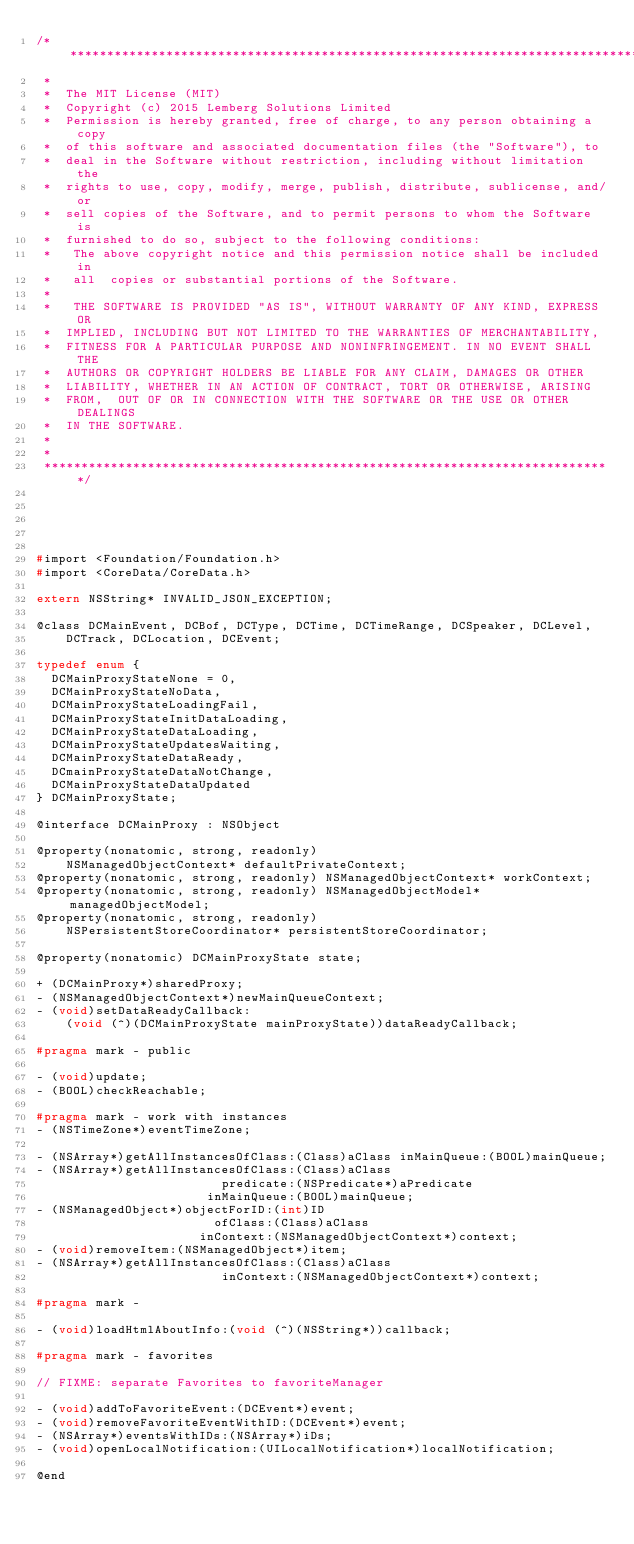<code> <loc_0><loc_0><loc_500><loc_500><_C_>/**********************************************************************************
 *                                                                           
 *  The MIT License (MIT)
 *  Copyright (c) 2015 Lemberg Solutions Limited
 *  Permission is hereby granted, free of charge, to any person obtaining a copy
 *  of this software and associated documentation files (the "Software"), to
 *  deal in the Software without restriction, including without limitation the 
 *  rights to use, copy, modify, merge, publish, distribute, sublicense, and/or
 *  sell copies of the Software, and to permit persons to whom the Software is
 *  furnished to do so, subject to the following conditions:
 *   The above copyright notice and this permission notice shall be included in
 *   all  copies or substantial portions of the Software.
 *
 *   THE SOFTWARE IS PROVIDED "AS IS", WITHOUT WARRANTY OF ANY KIND, EXPRESS OR
 *  IMPLIED, INCLUDING BUT NOT LIMITED TO THE WARRANTIES OF MERCHANTABILITY,
 *  FITNESS FOR A PARTICULAR PURPOSE AND NONINFRINGEMENT. IN NO EVENT SHALL THE
 *  AUTHORS OR COPYRIGHT HOLDERS BE LIABLE FOR ANY CLAIM, DAMAGES OR OTHER
 *  LIABILITY, WHETHER IN AN ACTION OF CONTRACT, TORT OR OTHERWISE, ARISING
 *  FROM,  OUT OF OR IN CONNECTION WITH THE SOFTWARE OR THE USE OR OTHER DEALINGS 
 *  IN THE SOFTWARE.
 *
 *                                                                           
 *****************************************************************************/





#import <Foundation/Foundation.h>
#import <CoreData/CoreData.h>

extern NSString* INVALID_JSON_EXCEPTION;

@class DCMainEvent, DCBof, DCType, DCTime, DCTimeRange, DCSpeaker, DCLevel,
    DCTrack, DCLocation, DCEvent;

typedef enum {
  DCMainProxyStateNone = 0,
  DCMainProxyStateNoData,
  DCMainProxyStateLoadingFail,
  DCMainProxyStateInitDataLoading,
  DCMainProxyStateDataLoading,
  DCMainProxyStateUpdatesWaiting,
  DCMainProxyStateDataReady,
  DCmainProxyStateDataNotChange,
  DCMainProxyStateDataUpdated
} DCMainProxyState;

@interface DCMainProxy : NSObject

@property(nonatomic, strong, readonly)
    NSManagedObjectContext* defaultPrivateContext;
@property(nonatomic, strong, readonly) NSManagedObjectContext* workContext;
@property(nonatomic, strong, readonly) NSManagedObjectModel* managedObjectModel;
@property(nonatomic, strong, readonly)
    NSPersistentStoreCoordinator* persistentStoreCoordinator;

@property(nonatomic) DCMainProxyState state;

+ (DCMainProxy*)sharedProxy;
- (NSManagedObjectContext*)newMainQueueContext;
- (void)setDataReadyCallback:
    (void (^)(DCMainProxyState mainProxyState))dataReadyCallback;

#pragma mark - public

- (void)update;
- (BOOL)checkReachable;

#pragma mark - work with instances
- (NSTimeZone*)eventTimeZone;

- (NSArray*)getAllInstancesOfClass:(Class)aClass inMainQueue:(BOOL)mainQueue;
- (NSArray*)getAllInstancesOfClass:(Class)aClass
                         predicate:(NSPredicate*)aPredicate
                       inMainQueue:(BOOL)mainQueue;
- (NSManagedObject*)objectForID:(int)ID
                        ofClass:(Class)aClass
                      inContext:(NSManagedObjectContext*)context;
- (void)removeItem:(NSManagedObject*)item;
- (NSArray*)getAllInstancesOfClass:(Class)aClass
                         inContext:(NSManagedObjectContext*)context;

#pragma mark -

- (void)loadHtmlAboutInfo:(void (^)(NSString*))callback;

#pragma mark - favorites

// FIXME: separate Favorites to favoriteManager

- (void)addToFavoriteEvent:(DCEvent*)event;
- (void)removeFavoriteEventWithID:(DCEvent*)event;
- (NSArray*)eventsWithIDs:(NSArray*)iDs;
- (void)openLocalNotification:(UILocalNotification*)localNotification;

@end
</code> 